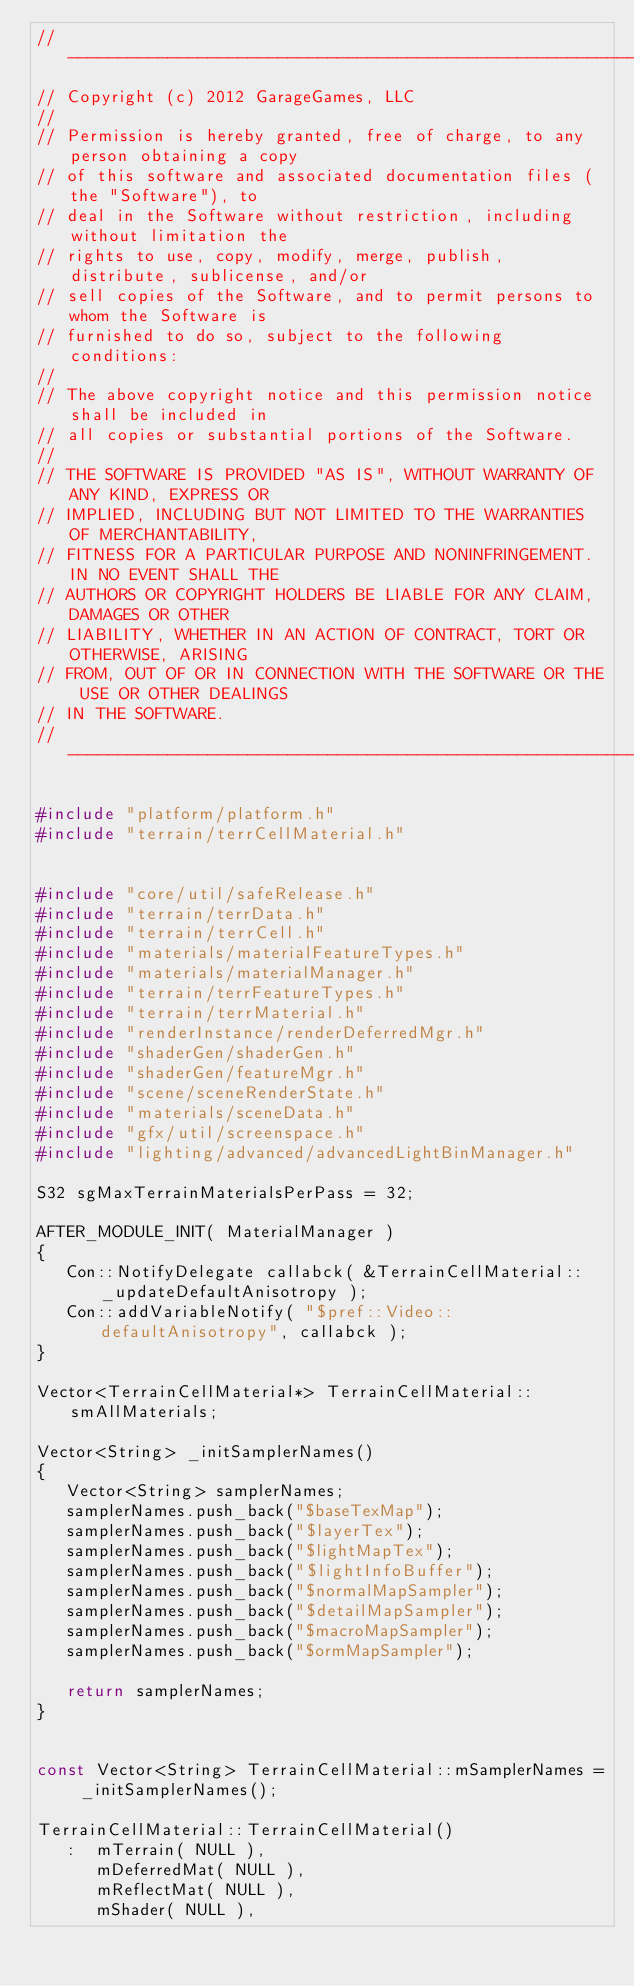Convert code to text. <code><loc_0><loc_0><loc_500><loc_500><_C++_>//-----------------------------------------------------------------------------
// Copyright (c) 2012 GarageGames, LLC
//
// Permission is hereby granted, free of charge, to any person obtaining a copy
// of this software and associated documentation files (the "Software"), to
// deal in the Software without restriction, including without limitation the
// rights to use, copy, modify, merge, publish, distribute, sublicense, and/or
// sell copies of the Software, and to permit persons to whom the Software is
// furnished to do so, subject to the following conditions:
//
// The above copyright notice and this permission notice shall be included in
// all copies or substantial portions of the Software.
//
// THE SOFTWARE IS PROVIDED "AS IS", WITHOUT WARRANTY OF ANY KIND, EXPRESS OR
// IMPLIED, INCLUDING BUT NOT LIMITED TO THE WARRANTIES OF MERCHANTABILITY,
// FITNESS FOR A PARTICULAR PURPOSE AND NONINFRINGEMENT. IN NO EVENT SHALL THE
// AUTHORS OR COPYRIGHT HOLDERS BE LIABLE FOR ANY CLAIM, DAMAGES OR OTHER
// LIABILITY, WHETHER IN AN ACTION OF CONTRACT, TORT OR OTHERWISE, ARISING
// FROM, OUT OF OR IN CONNECTION WITH THE SOFTWARE OR THE USE OR OTHER DEALINGS
// IN THE SOFTWARE.
//-----------------------------------------------------------------------------

#include "platform/platform.h"
#include "terrain/terrCellMaterial.h"


#include "core/util/safeRelease.h"
#include "terrain/terrData.h"
#include "terrain/terrCell.h"
#include "materials/materialFeatureTypes.h"
#include "materials/materialManager.h"
#include "terrain/terrFeatureTypes.h"
#include "terrain/terrMaterial.h"
#include "renderInstance/renderDeferredMgr.h"
#include "shaderGen/shaderGen.h"
#include "shaderGen/featureMgr.h"
#include "scene/sceneRenderState.h"
#include "materials/sceneData.h"
#include "gfx/util/screenspace.h"
#include "lighting/advanced/advancedLightBinManager.h"

S32 sgMaxTerrainMaterialsPerPass = 32;

AFTER_MODULE_INIT( MaterialManager )
{
   Con::NotifyDelegate callabck( &TerrainCellMaterial::_updateDefaultAnisotropy );
   Con::addVariableNotify( "$pref::Video::defaultAnisotropy", callabck );
}

Vector<TerrainCellMaterial*> TerrainCellMaterial::smAllMaterials;

Vector<String> _initSamplerNames()
{
   Vector<String> samplerNames;
   samplerNames.push_back("$baseTexMap");
   samplerNames.push_back("$layerTex");
   samplerNames.push_back("$lightMapTex");
   samplerNames.push_back("$lightInfoBuffer");
   samplerNames.push_back("$normalMapSampler");
   samplerNames.push_back("$detailMapSampler");
   samplerNames.push_back("$macroMapSampler");
   samplerNames.push_back("$ormMapSampler"); 

   return samplerNames;
}


const Vector<String> TerrainCellMaterial::mSamplerNames = _initSamplerNames();

TerrainCellMaterial::TerrainCellMaterial()
   :  mTerrain( NULL ),
      mDeferredMat( NULL ),
      mReflectMat( NULL ),
      mShader( NULL ),</code> 